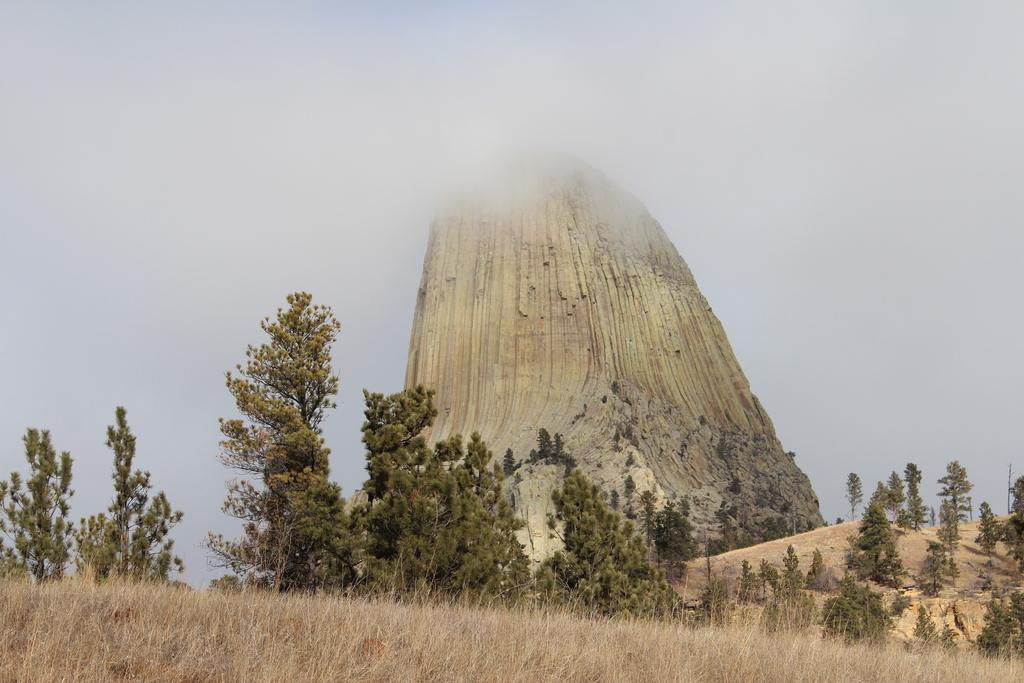What type of vegetation is located in the front of the image? There are bushes in the front of the image. What can be seen in the background of the image? There are trees and clouds visible in the background of the image. What part of the natural environment is visible in the image? The sky is visible in the background of the image. What advice is being given by the legs in the image? There are no legs present in the image, so no advice can be given. Is the park mentioned or visible in the image? There is no mention or visual representation of a park in the image. 